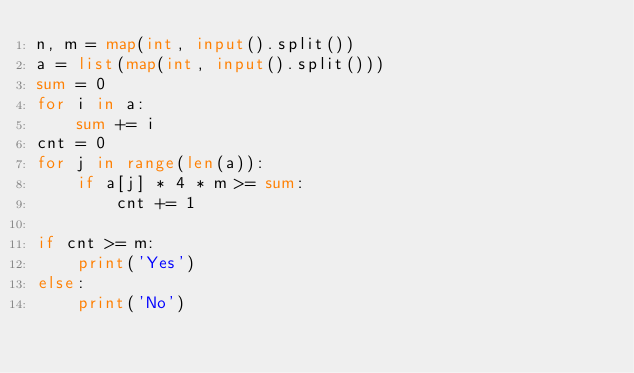Convert code to text. <code><loc_0><loc_0><loc_500><loc_500><_Python_>n, m = map(int, input().split())
a = list(map(int, input().split()))
sum = 0
for i in a:
	sum += i
cnt = 0
for j in range(len(a)):
	if a[j] * 4 * m >= sum:
		cnt += 1

if cnt >= m:
	print('Yes')
else:
	print('No')</code> 